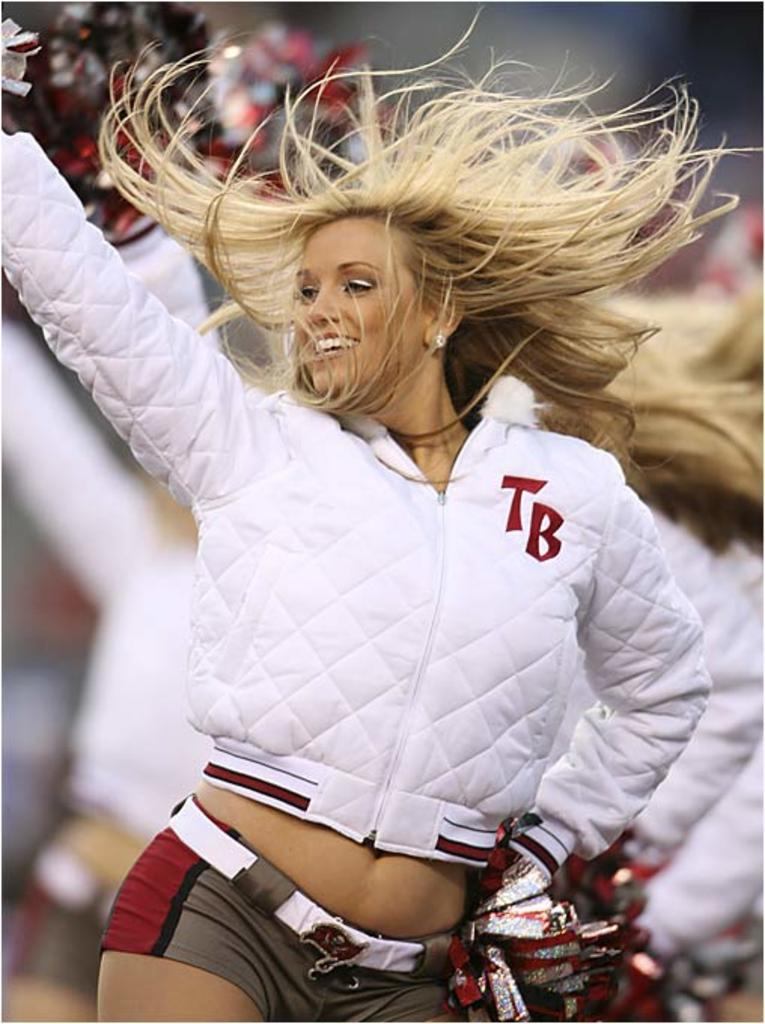What is the main subject of the image? There is a lady person in the image. What is the lady person wearing on her upper body? The lady person is wearing a white jacket. What is the lady person wearing on her lower body? The lady person is wearing brown shorts. What is the lady person wearing on her hands? The lady person is wearing gloves. What is the lady person doing in the image? The lady person is dancing. Can you see any worms crawling on the lady person's clothes in the image? No, there are no worms present in the image. 